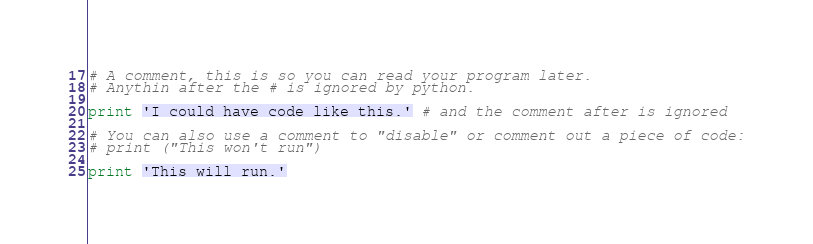Convert code to text. <code><loc_0><loc_0><loc_500><loc_500><_Python_># A comment, this is so you can read your program later.
# Anythin after the # is ignored by python.

print 'I could have code like this.' # and the comment after is ignored

# You can also use a comment to "disable" or comment out a piece of code:
# print ("This won't run")

print 'This will run.'
</code> 